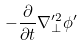<formula> <loc_0><loc_0><loc_500><loc_500>- \frac { \partial } { \partial t } \nabla _ { \perp } ^ { \prime 2 } \phi ^ { \prime }</formula> 